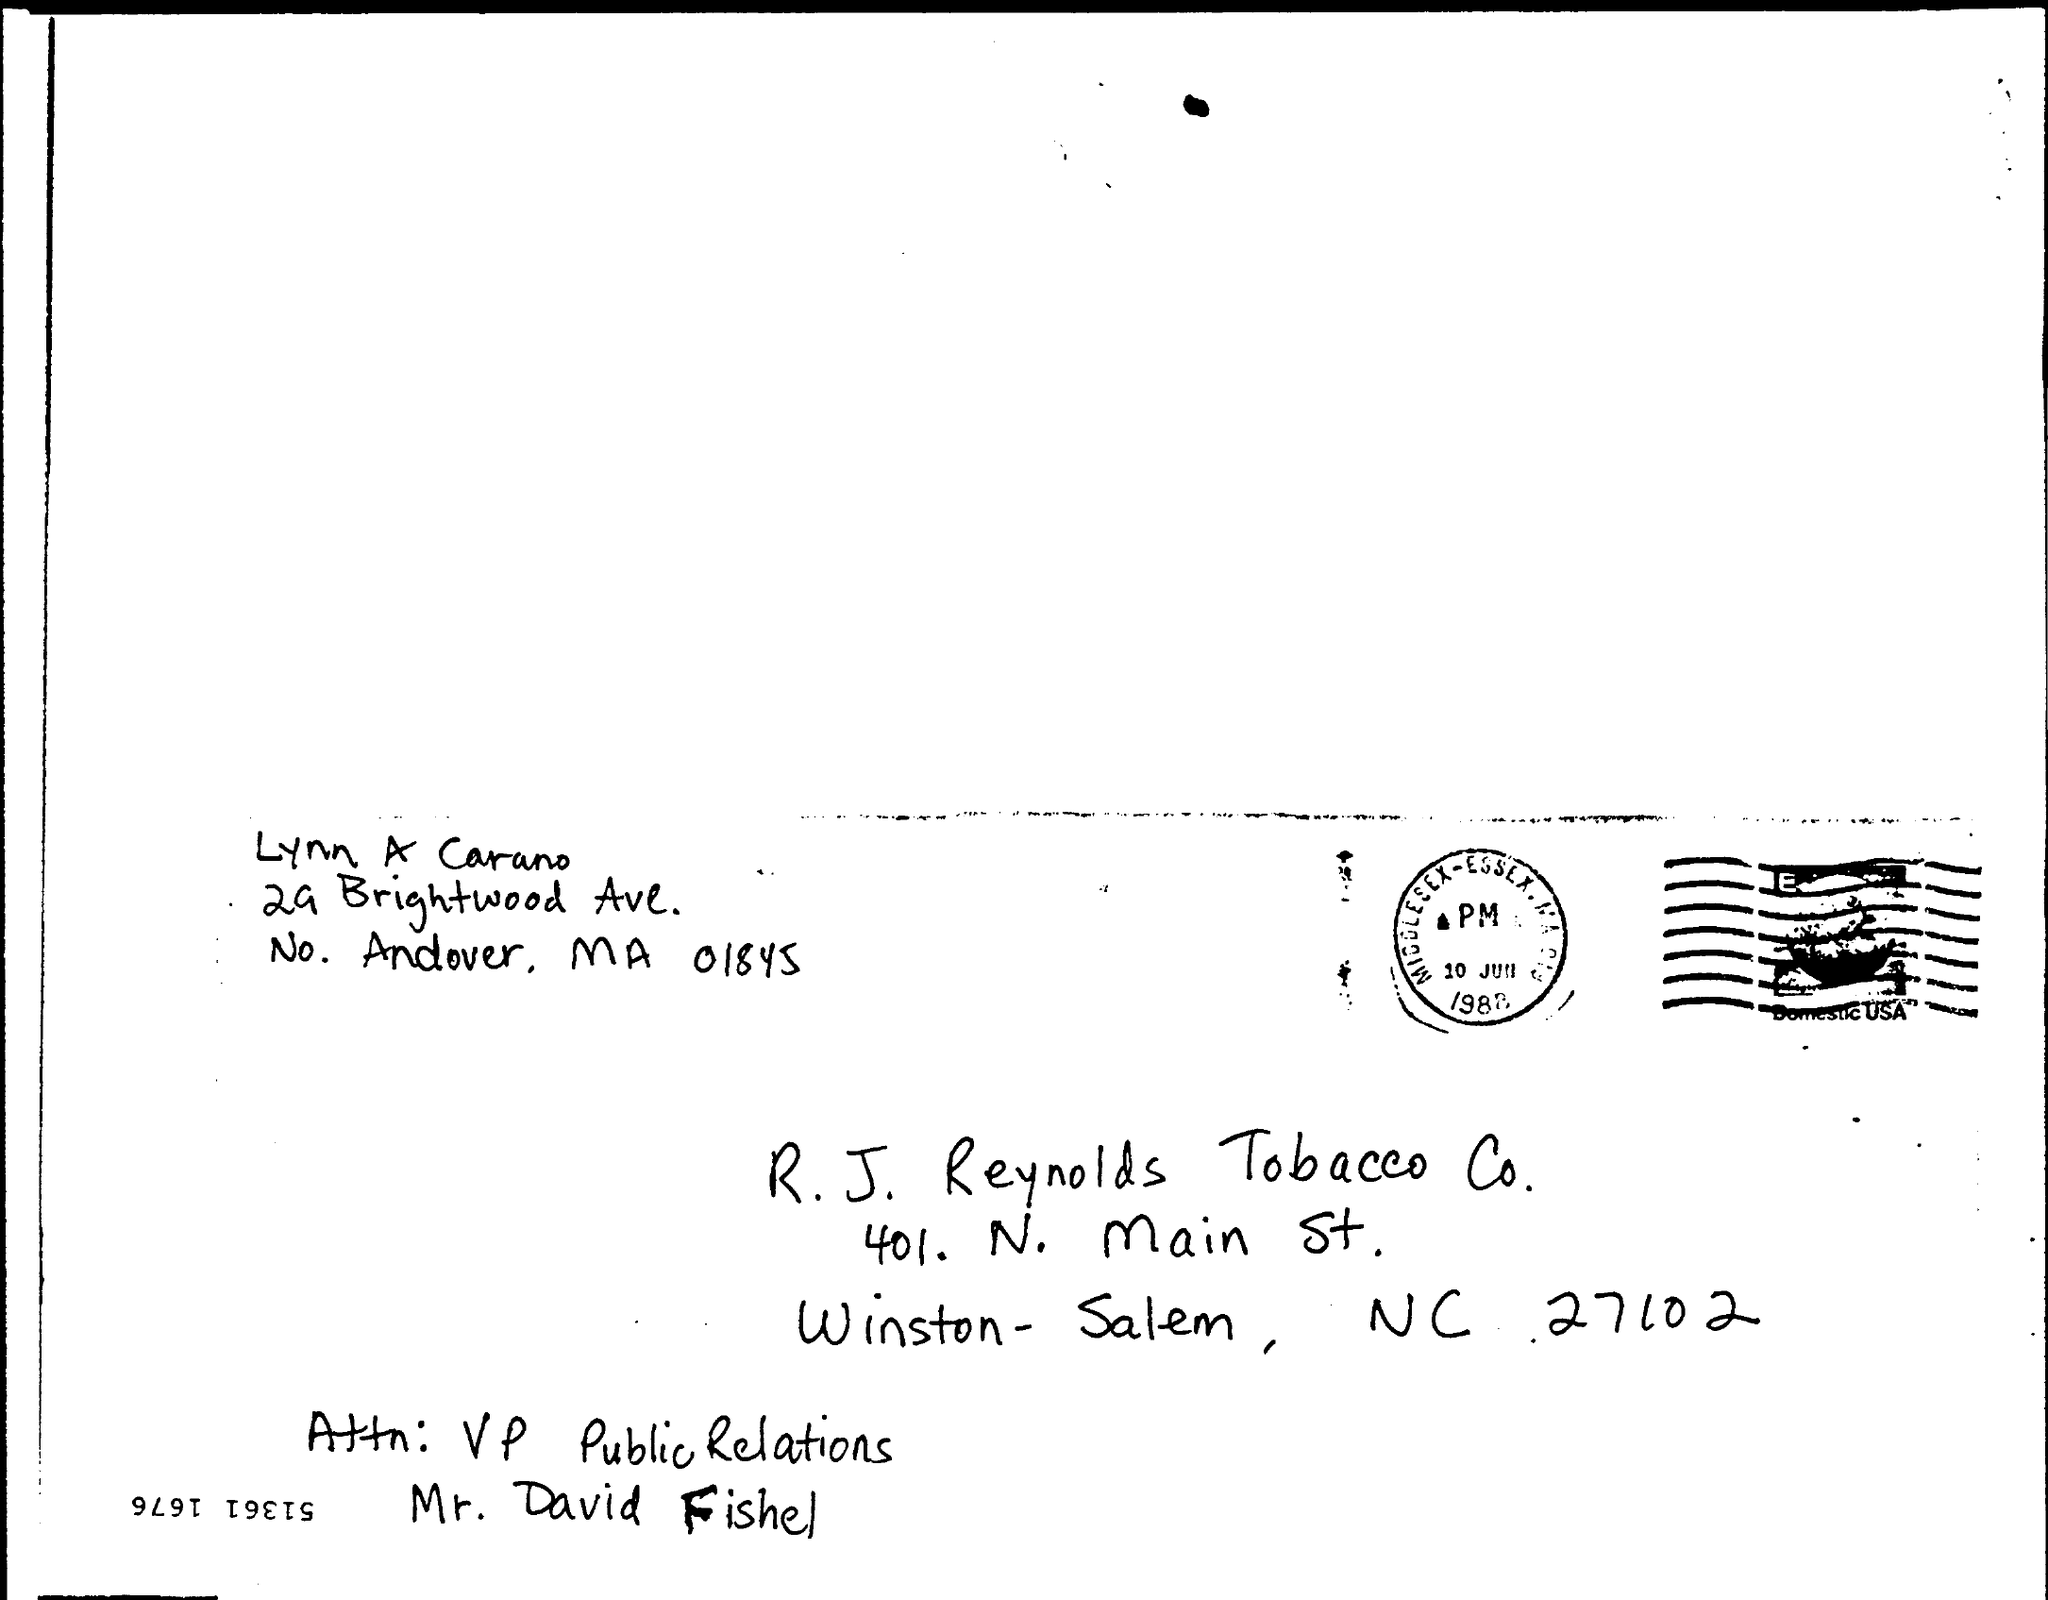From whom is the letter?
Offer a terse response. Lynn A Carano. 